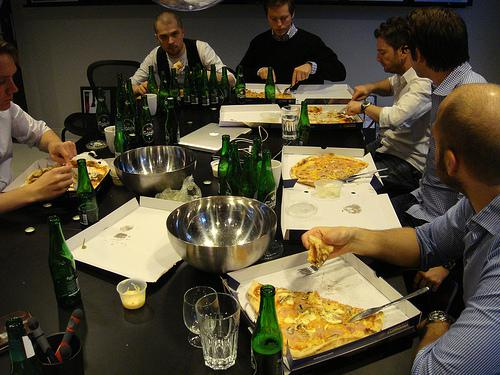Question: what are these people drinking?
Choices:
A. Pop.
B. Soda.
C. Apple juice.
D. Beer.
Answer with the letter. Answer: D Question: what are these people eating?
Choices:
A. Apples.
B. Bananas.
C. Peas.
D. Pizza.
Answer with the letter. Answer: D Question: how many people are visible?
Choices:
A. Four.
B. Two.
C. Eight.
D. Six.
Answer with the letter. Answer: D 